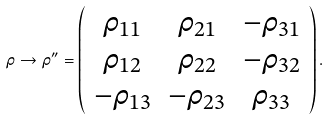<formula> <loc_0><loc_0><loc_500><loc_500>\rho \to \rho ^ { \prime \prime } = \left ( \begin{array} { c c c c } \rho _ { 1 1 } & \rho _ { 2 1 } & - \rho _ { 3 1 } \\ \rho _ { 1 2 } & \rho _ { 2 2 } & - \rho _ { 3 2 } \\ - \rho _ { 1 3 } & - \rho _ { 2 3 } & \rho _ { 3 3 } \end{array} \right ) .</formula> 